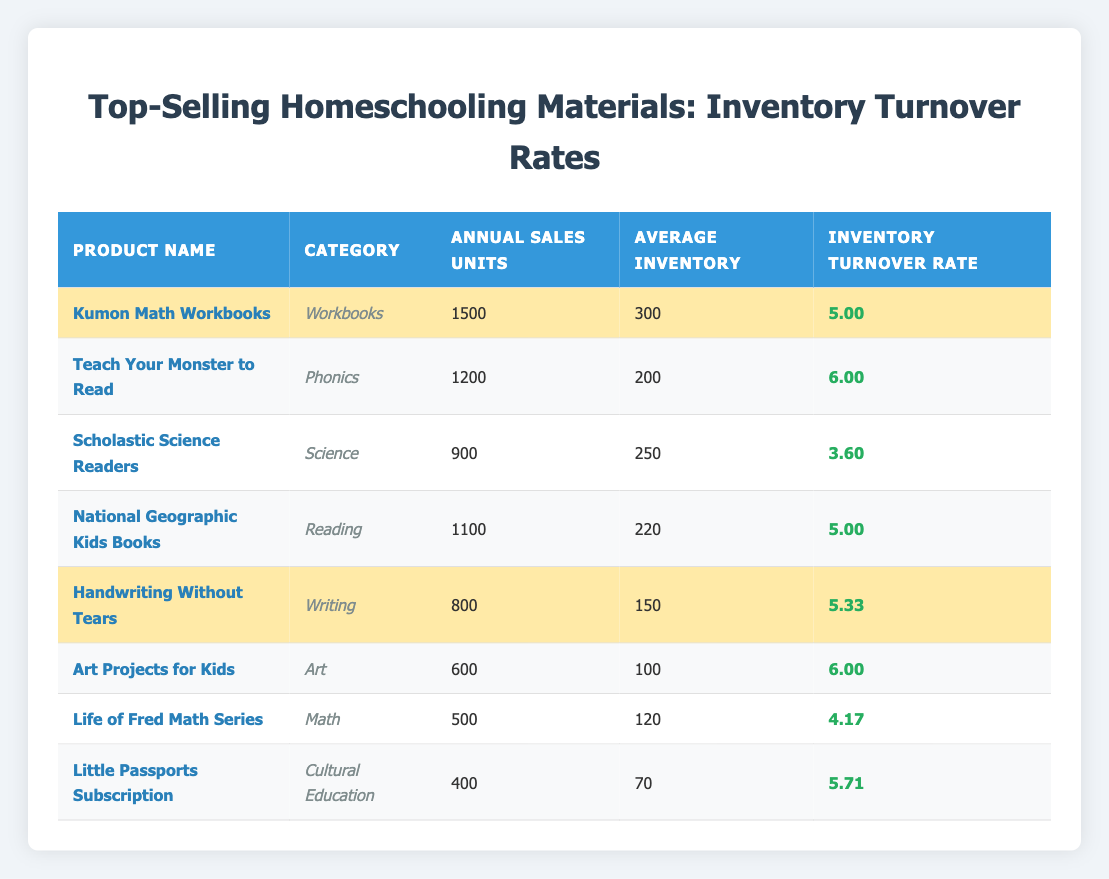What is the inventory turnover rate of "Teach Your Monster to Read"? The table lists "Teach Your Monster to Read" with an inventory turnover rate of 6.00.
Answer: 6.00 Which product has the highest inventory turnover rate? From the highlighted values, both "Teach Your Monster to Read" and "Art Projects for Kids" have the highest turnover rate at 6.00.
Answer: Teach Your Monster to Read and Art Projects for Kids What is the average inventory turnover rate of the highlighted products? The highlighted products have turnover rates of 5.00, 6.00, 5.00, 5.33, 6.00, and 5.71. The sum of these rates is 33.04, and there are 6 products, so the average is 33.04/6 = 5.51.
Answer: 5.51 How many products have an inventory turnover rate greater than 5.00? The highlighted products are "Teach Your Monster to Read," "Art Projects for Kids," "National Geographic Kids Books," "Handwriting Without Tears," and "Little Passports Subscription," totaling 5 that have rates greater than 5.00.
Answer: 5 What is the total annual sales units of all products listed in the table? The annual sales units are 1500 (Kumon) + 1200 (Teach Your Monster) + 900 (Scholastic) + 1100 (National Geographic) + 800 (Handwriting) + 600 (Art Projects) + 500 (Life of Fred) + 400 (Little Passports) = 5100.
Answer: 5100 Is the average inventory of "Scholastic Science Readers" lower than 300? The average inventory for "Scholastic Science Readers" is 250, which is indeed lower than 300.
Answer: Yes What is the difference between the highest and lowest inventory turnover rates among the products in the table? The highest turnover rate is 6.00 ("Teach Your Monster to Read" / "Art Projects for Kids") and the lowest is 3.60 ("Scholastic Science Readers"), so the difference is 6.00 - 3.60 = 2.40.
Answer: 2.40 Which category has the highest average annual sales units based on the products listed? Calculating the average for each category and their respective sales: Workbooks (1500), Phonics (1200), Science (900), Reading (1100), Writing (800), Art (600), Math (500), Cultural Education (400). The highest is from the Workbooks category with an average of 1500.
Answer: Workbooks How many products have an inventory turnover rate less than 5.00? Only one product, "Scholastic Science Readers," has an inventory turnover rate of 3.60, which is less than 5.00.
Answer: 1 